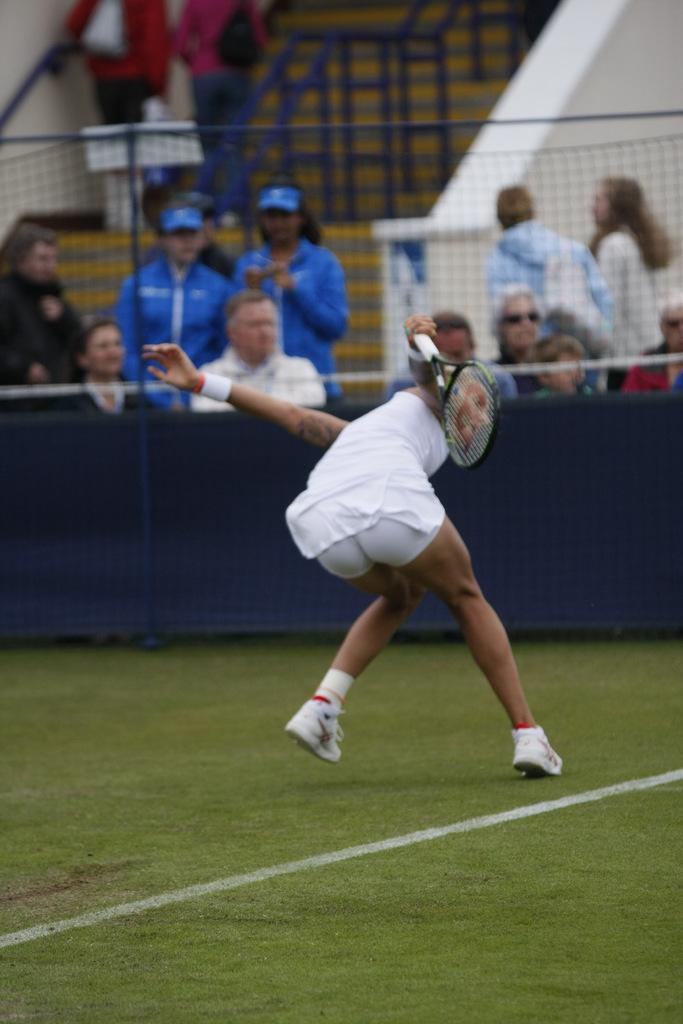What is happening in the image? There is a player on the field. What is the player wearing? The player is wearing a white dress and white shoes. What can be seen in the background of the image? There is a net in the image, and people are standing and sitting behind the net. Can you see any fire or whip being used by the player in the image? No, there is no fire or whip present in the image. 